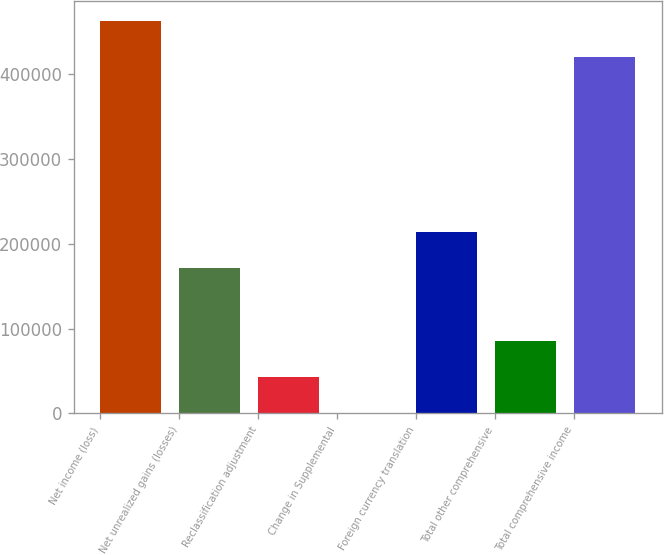<chart> <loc_0><loc_0><loc_500><loc_500><bar_chart><fcel>Net income (loss)<fcel>Net unrealized gains (losses)<fcel>Reclassification adjustment<fcel>Change in Supplemental<fcel>Foreign currency translation<fcel>Total other comprehensive<fcel>Total comprehensive income<nl><fcel>462606<fcel>171339<fcel>42882.8<fcel>64<fcel>214158<fcel>85701.6<fcel>419787<nl></chart> 